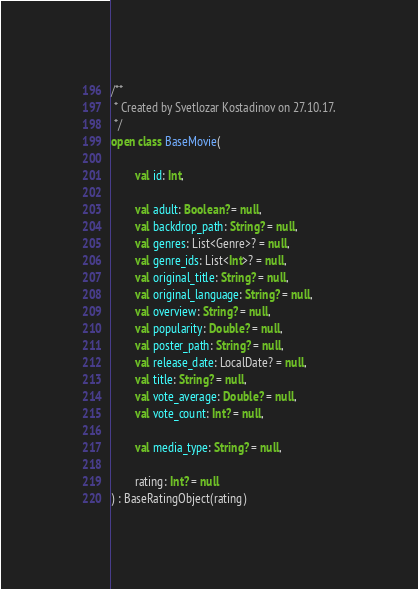Convert code to text. <code><loc_0><loc_0><loc_500><loc_500><_Kotlin_>
/**
 * Created by Svetlozar Kostadinov on 27.10.17.
 */
open class BaseMovie(

        val id: Int,

        val adult: Boolean? = null,
        val backdrop_path: String? = null,
        val genres: List<Genre>? = null,
        val genre_ids: List<Int>? = null,
        val original_title: String? = null,
        val original_language: String? = null,
        val overview: String? = null,
        val popularity: Double? = null,
        val poster_path: String? = null,
        val release_date: LocalDate? = null,
        val title: String? = null,
        val vote_average: Double? = null,
        val vote_count: Int? = null,

        val media_type: String? = null,

        rating: Int? = null
) : BaseRatingObject(rating)

</code> 